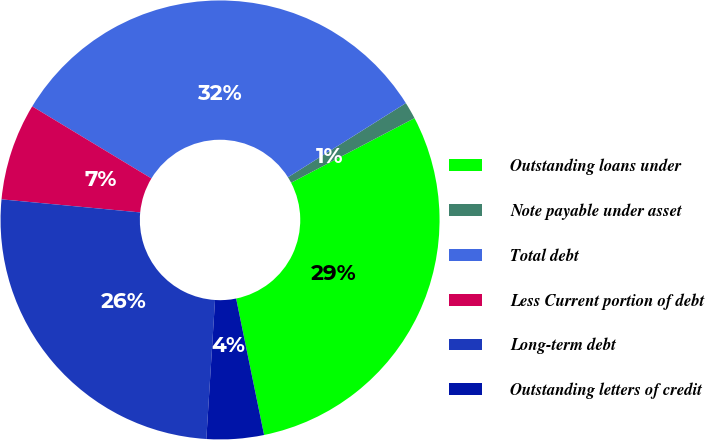Convert chart. <chart><loc_0><loc_0><loc_500><loc_500><pie_chart><fcel>Outstanding loans under<fcel>Note payable under asset<fcel>Total debt<fcel>Less Current portion of debt<fcel>Long-term debt<fcel>Outstanding letters of credit<nl><fcel>29.46%<fcel>1.26%<fcel>32.41%<fcel>7.16%<fcel>25.5%<fcel>4.21%<nl></chart> 